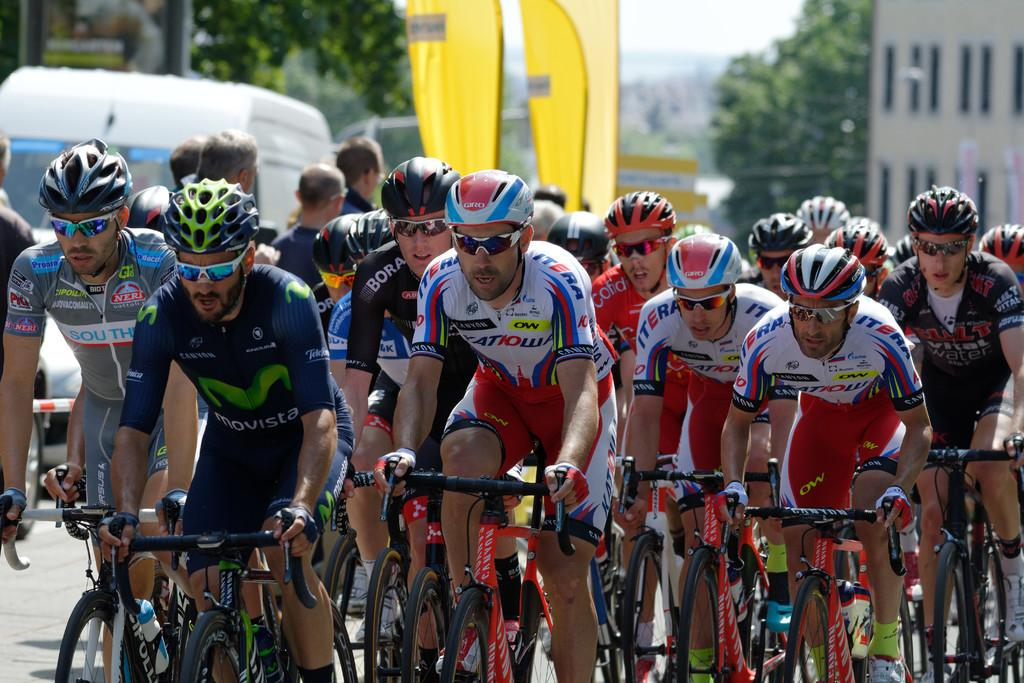How many people are in the image? There is a group of persons in the image. What are the persons doing in the image? The persons are riding bicycles. What can be seen in the background of the image? There are trees, buildings, and vehicles moving on the road in the background of the image. Can you tell me how many lizards are sitting on the grandmother's lap in the image? There is no grandmother or lizards present in the image. 